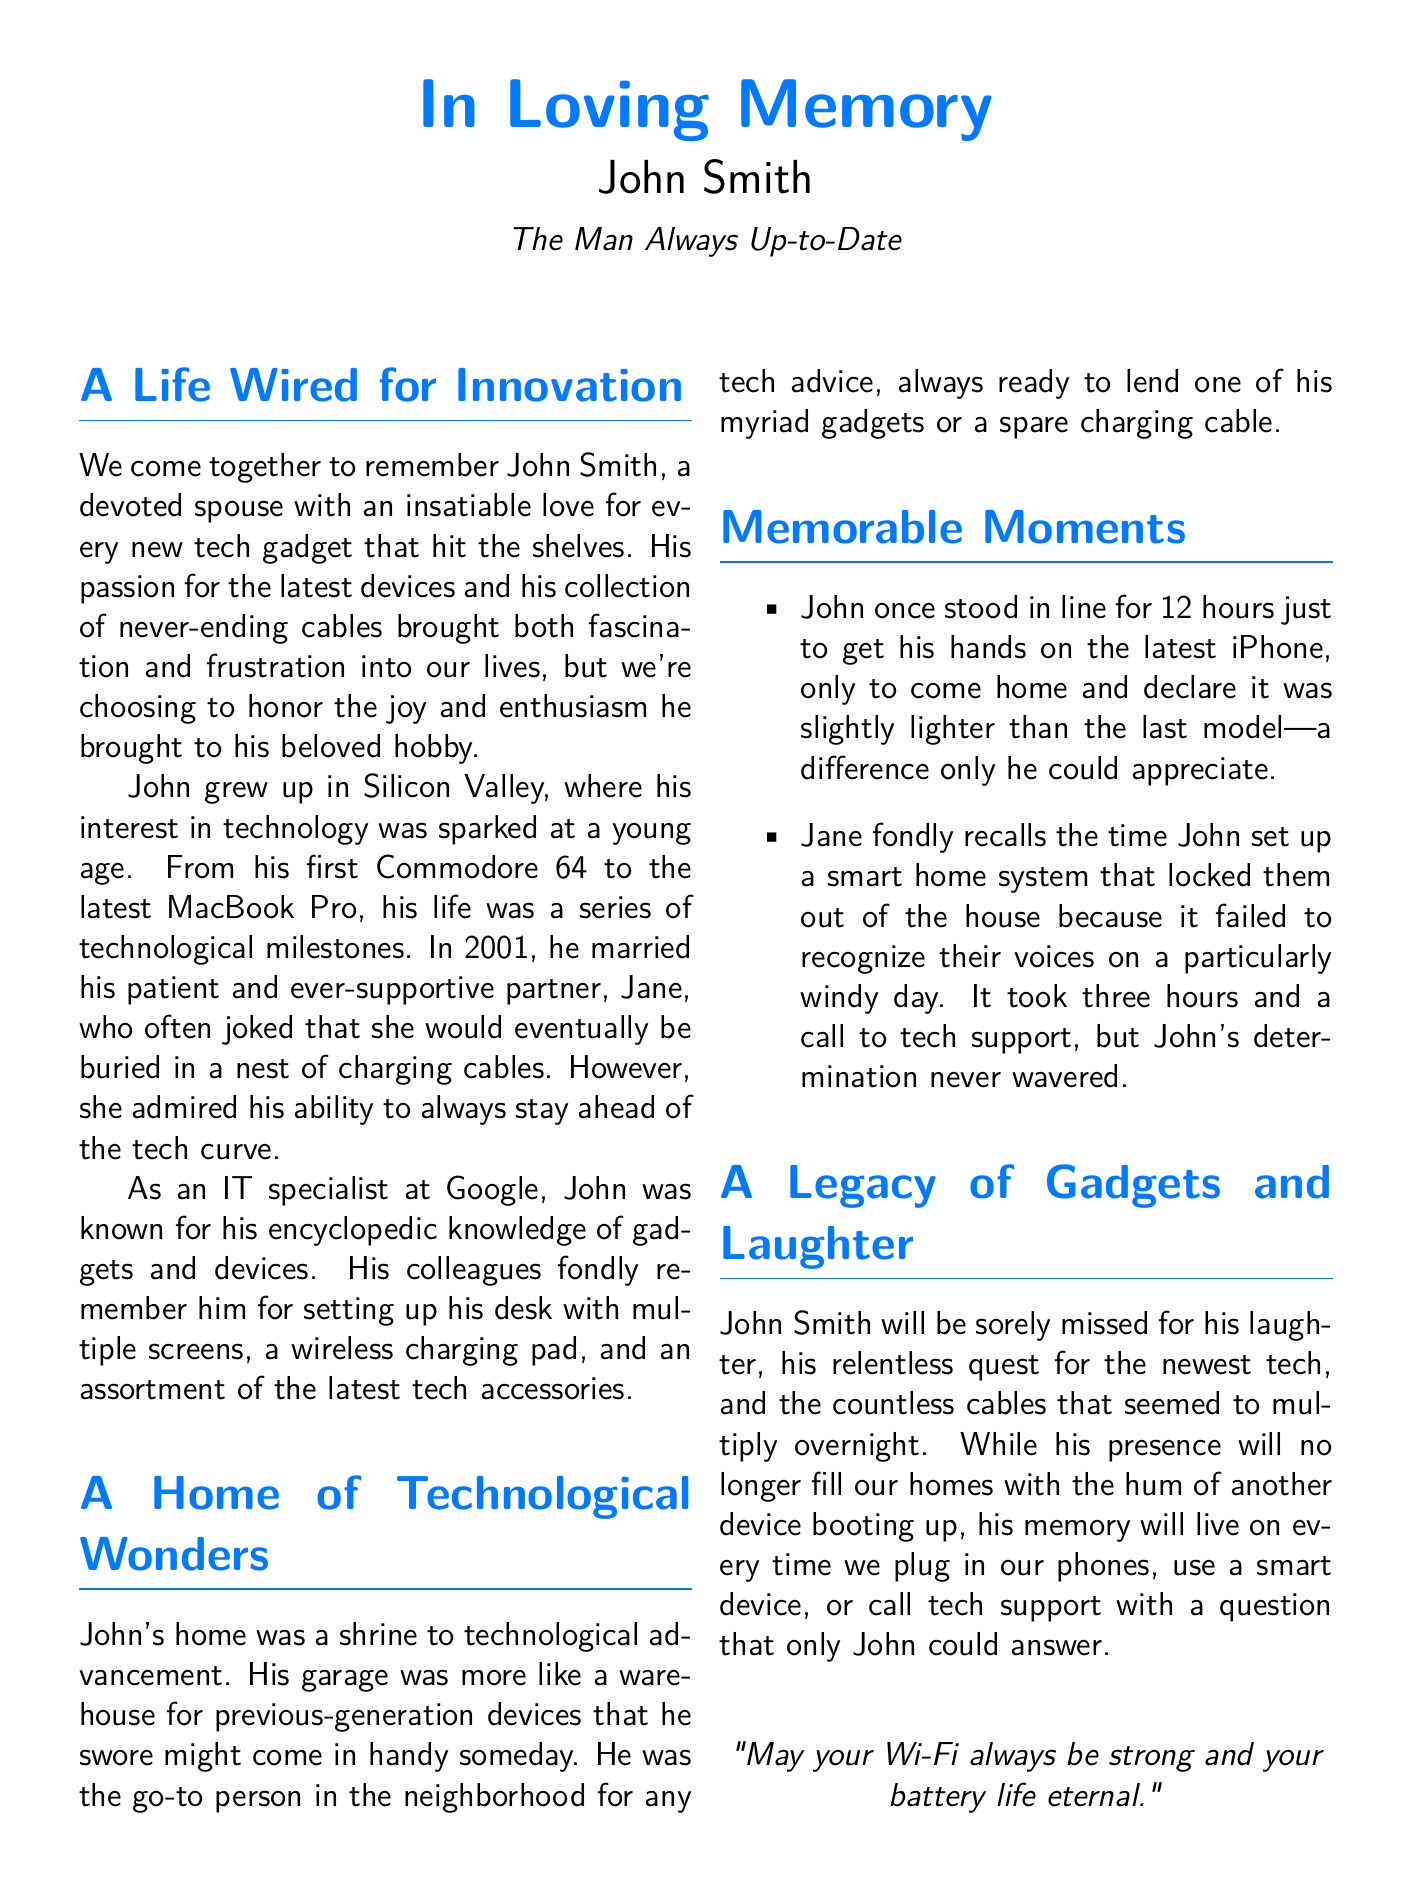What was John's full name? John's full name is mentioned at the start of the obituary.
Answer: John Smith What year did John marry Jane? The document specifies the year when John got married.
Answer: 2001 What was John’s profession? The document states his occupation clearly.
Answer: IT specialist Which gadget was John excited about in the anecdote? The anecdote about John standing in line refers to a specific gadget.
Answer: iPhone How long did John wait in line for the iPhone? The document includes the exact duration of John's wait for the iPhone.
Answer: 12 hours What was Jane's humorous remark about cables? The document includes Jane’s humor regarding their home.
Answer: Buried in a nest of charging cables What did John’s home resemble? The document describes a specific characteristic of John's home.
Answer: A shrine to technological advancement What did John often set up on his desk? The document lists items that John had on his desk.
Answer: Multiple screens What does the final quote express? The quote at the bottom conveys a specific wish or sentiment.
Answer: Strong Wi-Fi and eternal battery life 